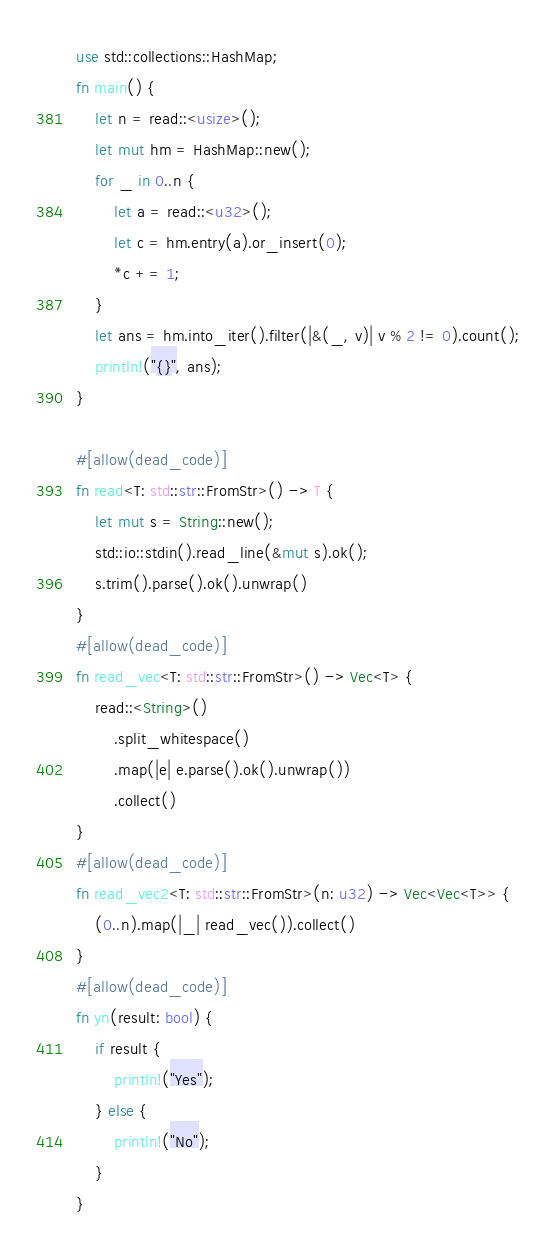Convert code to text. <code><loc_0><loc_0><loc_500><loc_500><_Rust_>use std::collections::HashMap;
fn main() {
    let n = read::<usize>();
    let mut hm = HashMap::new();
    for _ in 0..n {
        let a = read::<u32>();
        let c = hm.entry(a).or_insert(0);
        *c += 1;
    }
    let ans = hm.into_iter().filter(|&(_, v)| v % 2 != 0).count();
    println!("{}", ans);
}

#[allow(dead_code)]
fn read<T: std::str::FromStr>() -> T {
    let mut s = String::new();
    std::io::stdin().read_line(&mut s).ok();
    s.trim().parse().ok().unwrap()
}
#[allow(dead_code)]
fn read_vec<T: std::str::FromStr>() -> Vec<T> {
    read::<String>()
        .split_whitespace()
        .map(|e| e.parse().ok().unwrap())
        .collect()
}
#[allow(dead_code)]
fn read_vec2<T: std::str::FromStr>(n: u32) -> Vec<Vec<T>> {
    (0..n).map(|_| read_vec()).collect()
}
#[allow(dead_code)]
fn yn(result: bool) {
    if result {
        println!("Yes");
    } else {
        println!("No");
    }
}
</code> 